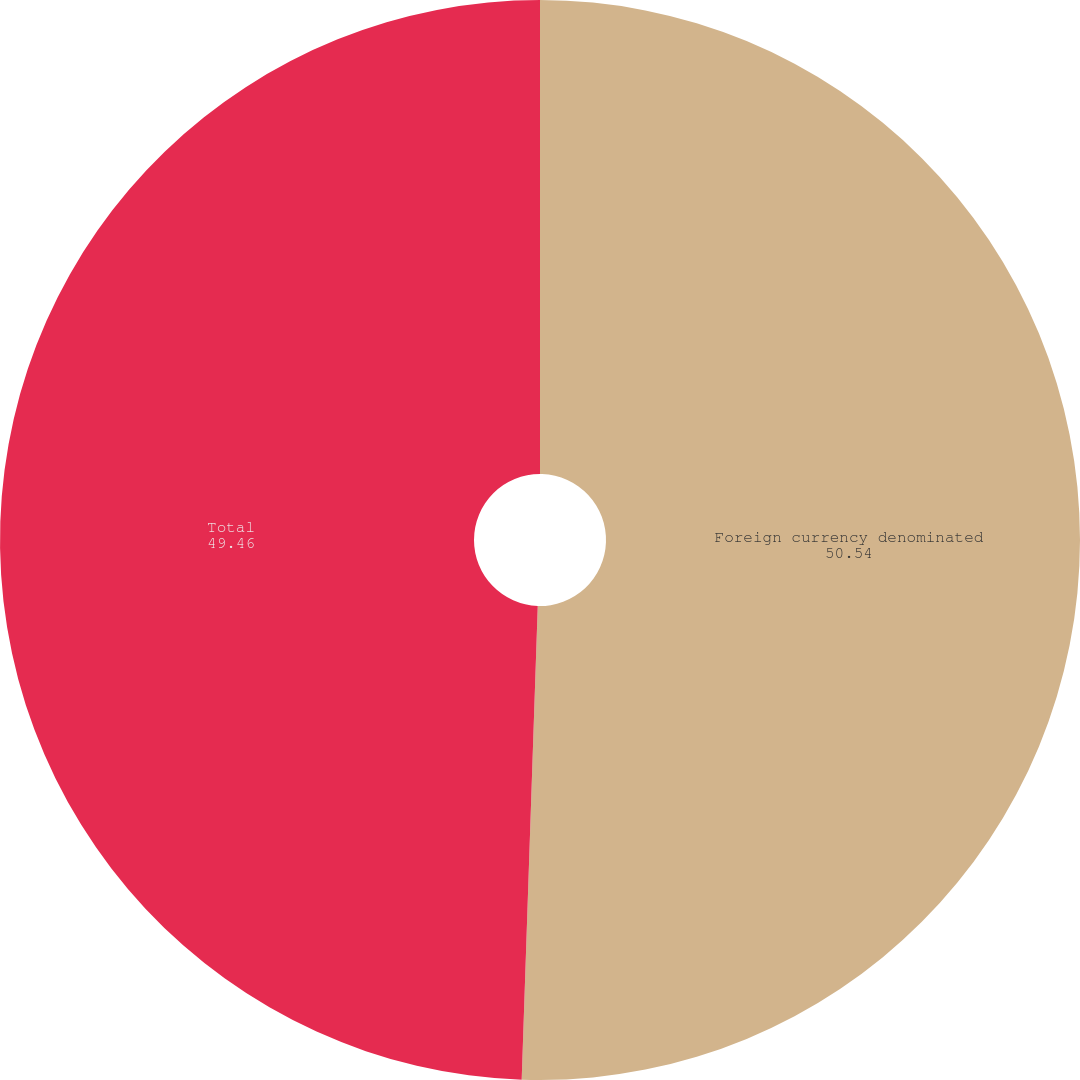<chart> <loc_0><loc_0><loc_500><loc_500><pie_chart><fcel>Foreign currency denominated<fcel>Total<nl><fcel>50.54%<fcel>49.46%<nl></chart> 